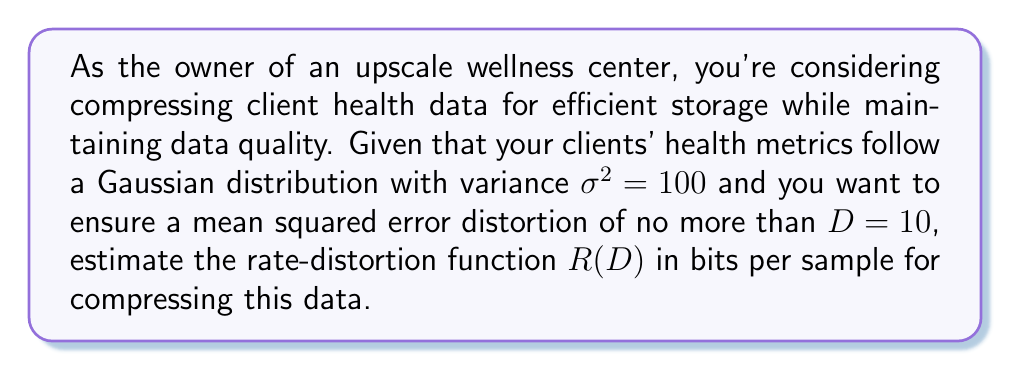What is the answer to this math problem? To estimate the rate-distortion function for compressing client health data, we'll follow these steps:

1) For a Gaussian source with variance $\sigma^2$ and a mean squared error distortion measure, the rate-distortion function is given by:

   $$R(D) = \begin{cases}
   \frac{1}{2}\log_2\left(\frac{\sigma^2}{D}\right) & \text{if } 0 \leq D \leq \sigma^2 \\
   0 & \text{if } D > \sigma^2
   \end{cases}$$

2) We're given that $\sigma^2 = 100$ and $D = 10$. Let's first check if $0 \leq D \leq \sigma^2$:

   $0 \leq 10 \leq 100$

   This condition is satisfied, so we can use the first case of the rate-distortion function.

3) Now, let's substitute the values into the equation:

   $$R(D) = \frac{1}{2}\log_2\left(\frac{100}{10}\right)$$

4) Simplify inside the logarithm:

   $$R(D) = \frac{1}{2}\log_2(10)$$

5) Calculate the logarithm:

   $$R(D) = \frac{1}{2} \cdot 3.32 \approx 1.66$$

Therefore, the rate-distortion function for compressing the client health data is approximately 1.66 bits per sample.

This means that to achieve a mean squared error distortion of no more than 10, you need to use at least 1.66 bits per sample on average when compressing the data. This ensures that the compressed data maintains sufficient quality for your upscale wellness center's standards.
Answer: $R(D) \approx 1.66$ bits per sample 